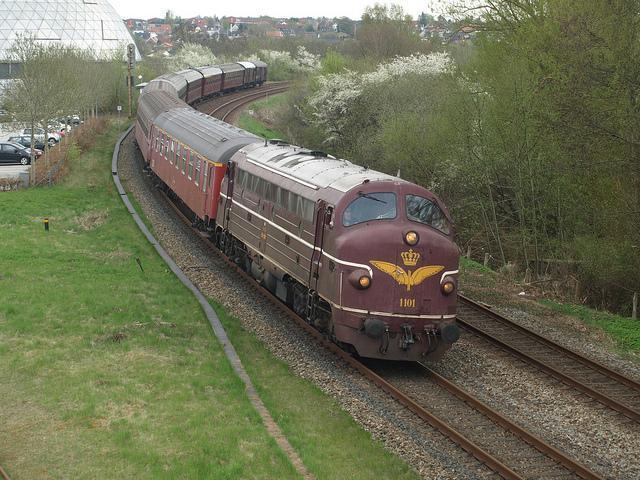What wrestler is named after the long item with the wing logo?
Select the accurate answer and provide explanation: 'Answer: answer
Rationale: rationale.'
Options: Tugboat, tank abbott, a-train, refrigerator perry. Answer: a-train.
Rationale: Mathew bloom was known as a-train which is what the first car would be. 